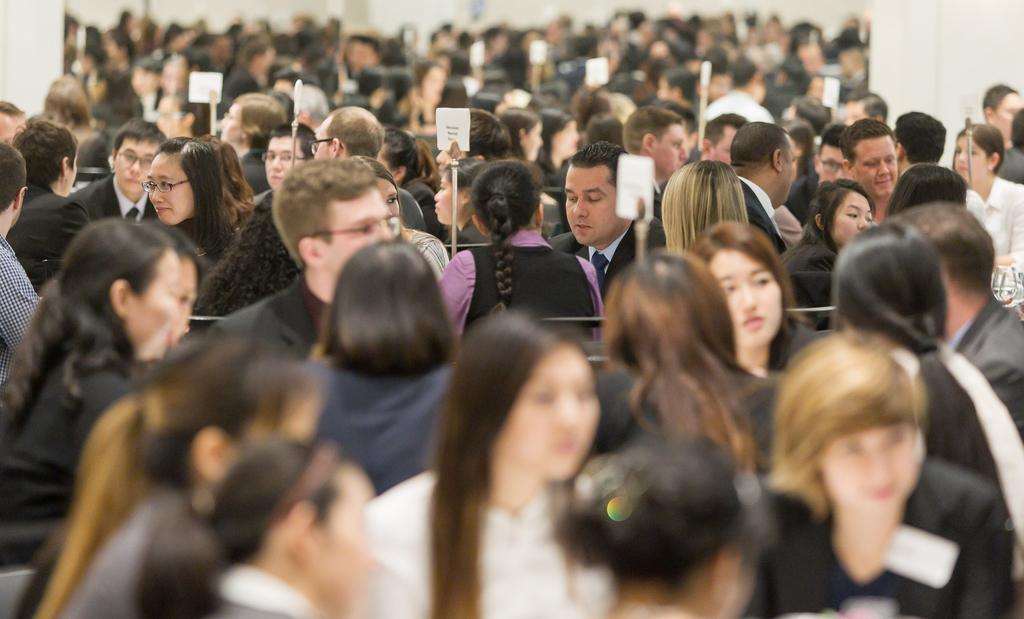What is happening in the image? There is a group of people sitting in the image. Can you describe the appearance of one of the individuals? One person is wearing spectacles and a coat. What can be seen in the background of the image? There are sign boards visible in the background of the image. What type of thrill can be seen on the faces of the people in the image? There is no indication of any specific emotion or thrill on the faces of the people in the image. Is anyone wearing a scarf in the image? The provided facts do not mention any scarves being worn by the people in the image. 